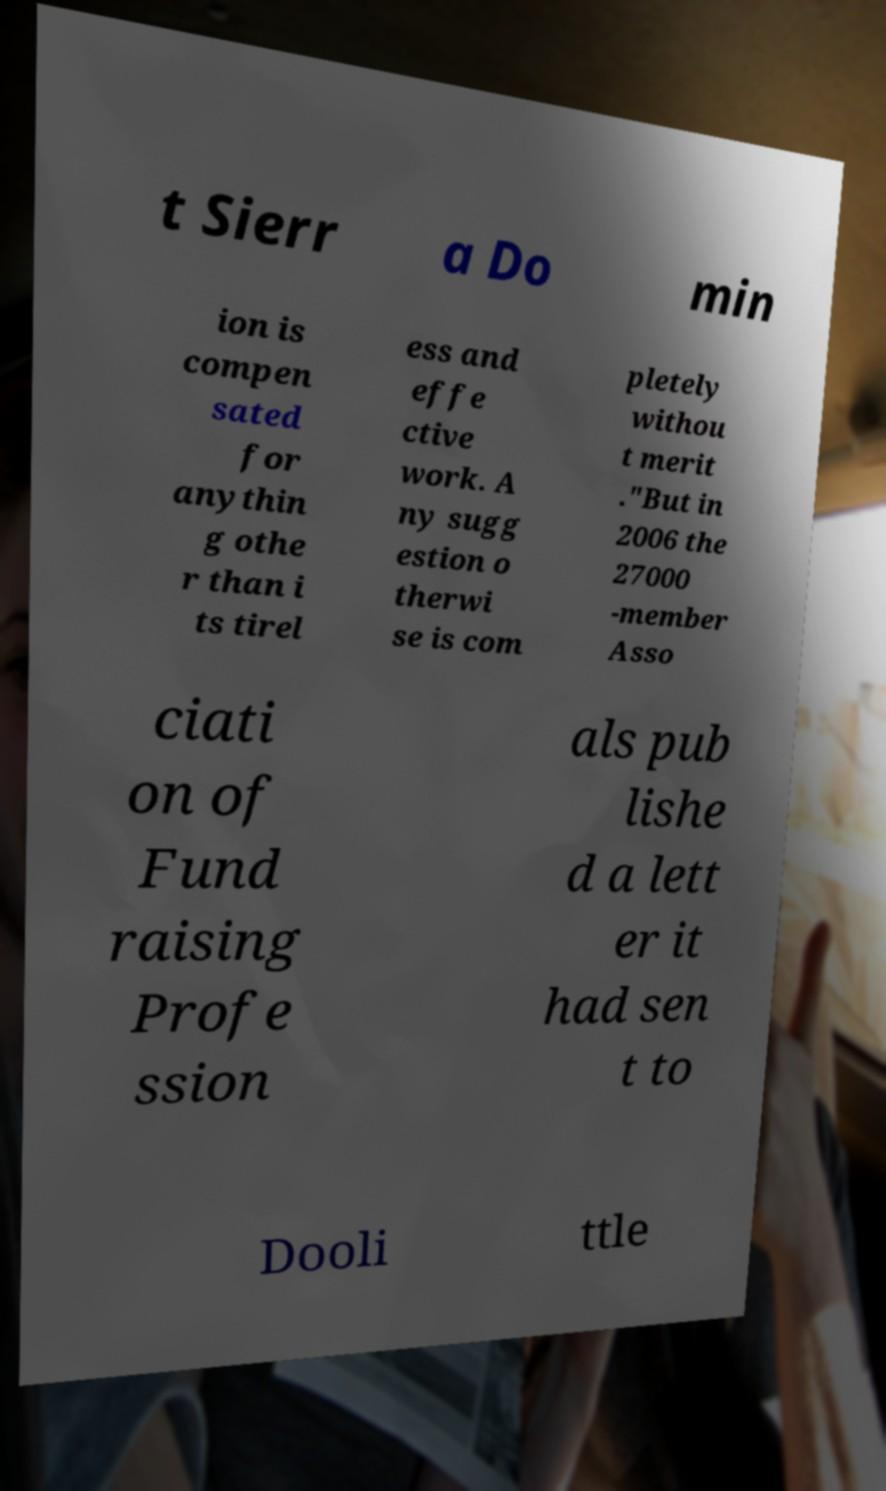What messages or text are displayed in this image? I need them in a readable, typed format. t Sierr a Do min ion is compen sated for anythin g othe r than i ts tirel ess and effe ctive work. A ny sugg estion o therwi se is com pletely withou t merit ."But in 2006 the 27000 -member Asso ciati on of Fund raising Profe ssion als pub lishe d a lett er it had sen t to Dooli ttle 